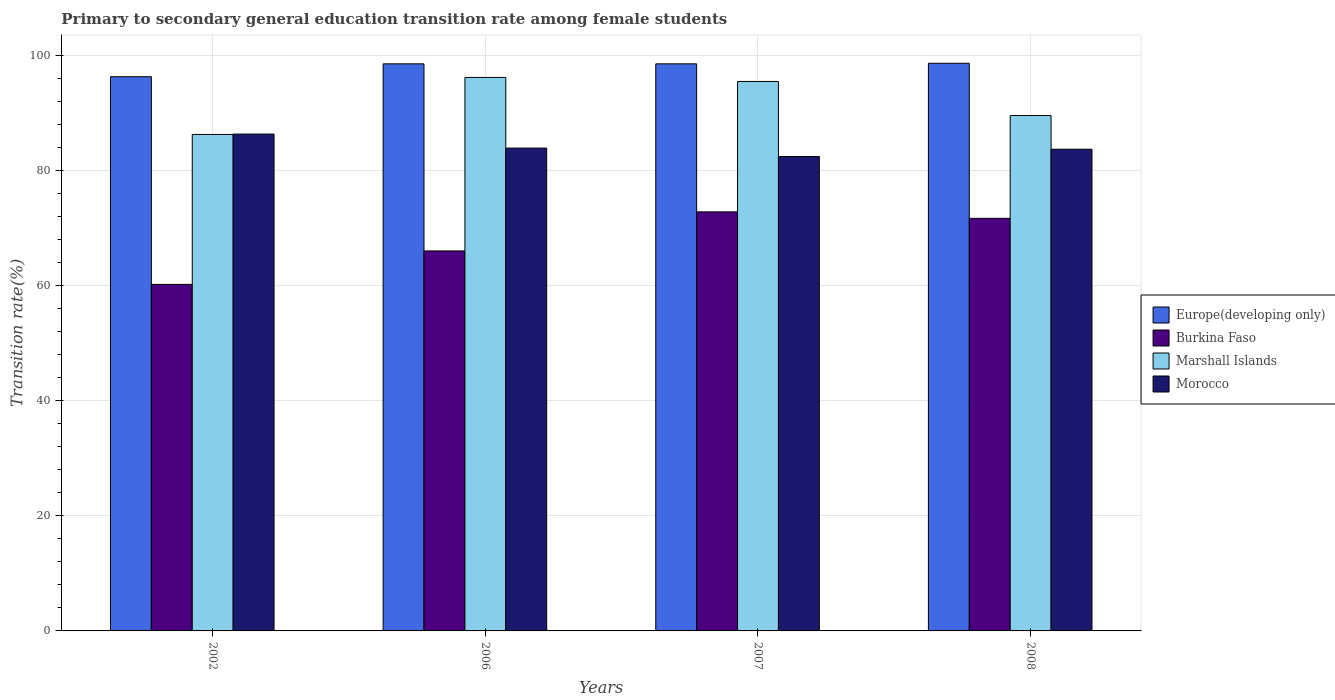How many different coloured bars are there?
Keep it short and to the point. 4. How many groups of bars are there?
Give a very brief answer. 4. How many bars are there on the 2nd tick from the left?
Provide a succinct answer. 4. What is the label of the 4th group of bars from the left?
Your answer should be very brief. 2008. In how many cases, is the number of bars for a given year not equal to the number of legend labels?
Your answer should be very brief. 0. What is the transition rate in Burkina Faso in 2008?
Make the answer very short. 71.7. Across all years, what is the maximum transition rate in Europe(developing only)?
Offer a terse response. 98.65. Across all years, what is the minimum transition rate in Europe(developing only)?
Your answer should be very brief. 96.31. In which year was the transition rate in Europe(developing only) minimum?
Provide a short and direct response. 2002. What is the total transition rate in Burkina Faso in the graph?
Offer a very short reply. 270.77. What is the difference between the transition rate in Morocco in 2006 and that in 2007?
Offer a terse response. 1.47. What is the difference between the transition rate in Marshall Islands in 2008 and the transition rate in Burkina Faso in 2007?
Your answer should be compact. 16.74. What is the average transition rate in Morocco per year?
Your answer should be very brief. 84.1. In the year 2008, what is the difference between the transition rate in Morocco and transition rate in Europe(developing only)?
Your response must be concise. -14.94. In how many years, is the transition rate in Marshall Islands greater than 20 %?
Ensure brevity in your answer.  4. What is the ratio of the transition rate in Burkina Faso in 2006 to that in 2008?
Provide a succinct answer. 0.92. What is the difference between the highest and the second highest transition rate in Europe(developing only)?
Ensure brevity in your answer.  0.1. What is the difference between the highest and the lowest transition rate in Marshall Islands?
Keep it short and to the point. 9.91. In how many years, is the transition rate in Marshall Islands greater than the average transition rate in Marshall Islands taken over all years?
Offer a very short reply. 2. Is it the case that in every year, the sum of the transition rate in Morocco and transition rate in Europe(developing only) is greater than the sum of transition rate in Marshall Islands and transition rate in Burkina Faso?
Offer a very short reply. No. What does the 2nd bar from the left in 2006 represents?
Provide a short and direct response. Burkina Faso. What does the 2nd bar from the right in 2002 represents?
Your answer should be compact. Marshall Islands. Is it the case that in every year, the sum of the transition rate in Morocco and transition rate in Burkina Faso is greater than the transition rate in Europe(developing only)?
Provide a short and direct response. Yes. How many bars are there?
Provide a short and direct response. 16. What is the difference between two consecutive major ticks on the Y-axis?
Your answer should be very brief. 20. Are the values on the major ticks of Y-axis written in scientific E-notation?
Provide a short and direct response. No. Does the graph contain grids?
Provide a short and direct response. Yes. How many legend labels are there?
Keep it short and to the point. 4. How are the legend labels stacked?
Ensure brevity in your answer.  Vertical. What is the title of the graph?
Give a very brief answer. Primary to secondary general education transition rate among female students. What is the label or title of the Y-axis?
Provide a succinct answer. Transition rate(%). What is the Transition rate(%) of Europe(developing only) in 2002?
Provide a short and direct response. 96.31. What is the Transition rate(%) in Burkina Faso in 2002?
Provide a short and direct response. 60.22. What is the Transition rate(%) in Marshall Islands in 2002?
Ensure brevity in your answer.  86.27. What is the Transition rate(%) of Morocco in 2002?
Keep it short and to the point. 86.34. What is the Transition rate(%) in Europe(developing only) in 2006?
Offer a terse response. 98.55. What is the Transition rate(%) of Burkina Faso in 2006?
Offer a very short reply. 66.03. What is the Transition rate(%) of Marshall Islands in 2006?
Give a very brief answer. 96.19. What is the Transition rate(%) of Morocco in 2006?
Provide a succinct answer. 83.91. What is the Transition rate(%) of Europe(developing only) in 2007?
Make the answer very short. 98.55. What is the Transition rate(%) in Burkina Faso in 2007?
Offer a terse response. 72.82. What is the Transition rate(%) in Marshall Islands in 2007?
Keep it short and to the point. 95.48. What is the Transition rate(%) of Morocco in 2007?
Offer a very short reply. 82.44. What is the Transition rate(%) of Europe(developing only) in 2008?
Offer a terse response. 98.65. What is the Transition rate(%) in Burkina Faso in 2008?
Your answer should be compact. 71.7. What is the Transition rate(%) in Marshall Islands in 2008?
Keep it short and to the point. 89.57. What is the Transition rate(%) of Morocco in 2008?
Make the answer very short. 83.71. Across all years, what is the maximum Transition rate(%) of Europe(developing only)?
Ensure brevity in your answer.  98.65. Across all years, what is the maximum Transition rate(%) in Burkina Faso?
Offer a very short reply. 72.82. Across all years, what is the maximum Transition rate(%) in Marshall Islands?
Your answer should be compact. 96.19. Across all years, what is the maximum Transition rate(%) of Morocco?
Ensure brevity in your answer.  86.34. Across all years, what is the minimum Transition rate(%) of Europe(developing only)?
Your answer should be very brief. 96.31. Across all years, what is the minimum Transition rate(%) in Burkina Faso?
Your answer should be very brief. 60.22. Across all years, what is the minimum Transition rate(%) of Marshall Islands?
Keep it short and to the point. 86.27. Across all years, what is the minimum Transition rate(%) of Morocco?
Offer a terse response. 82.44. What is the total Transition rate(%) in Europe(developing only) in the graph?
Your answer should be very brief. 392.06. What is the total Transition rate(%) in Burkina Faso in the graph?
Your response must be concise. 270.77. What is the total Transition rate(%) in Marshall Islands in the graph?
Your answer should be compact. 367.51. What is the total Transition rate(%) in Morocco in the graph?
Provide a short and direct response. 336.4. What is the difference between the Transition rate(%) of Europe(developing only) in 2002 and that in 2006?
Make the answer very short. -2.24. What is the difference between the Transition rate(%) of Burkina Faso in 2002 and that in 2006?
Your answer should be very brief. -5.82. What is the difference between the Transition rate(%) in Marshall Islands in 2002 and that in 2006?
Your response must be concise. -9.91. What is the difference between the Transition rate(%) of Morocco in 2002 and that in 2006?
Your answer should be very brief. 2.44. What is the difference between the Transition rate(%) of Europe(developing only) in 2002 and that in 2007?
Your answer should be very brief. -2.24. What is the difference between the Transition rate(%) in Burkina Faso in 2002 and that in 2007?
Offer a very short reply. -12.6. What is the difference between the Transition rate(%) in Marshall Islands in 2002 and that in 2007?
Make the answer very short. -9.21. What is the difference between the Transition rate(%) in Morocco in 2002 and that in 2007?
Your response must be concise. 3.9. What is the difference between the Transition rate(%) of Europe(developing only) in 2002 and that in 2008?
Make the answer very short. -2.34. What is the difference between the Transition rate(%) in Burkina Faso in 2002 and that in 2008?
Provide a succinct answer. -11.48. What is the difference between the Transition rate(%) in Marshall Islands in 2002 and that in 2008?
Give a very brief answer. -3.29. What is the difference between the Transition rate(%) in Morocco in 2002 and that in 2008?
Offer a terse response. 2.63. What is the difference between the Transition rate(%) in Europe(developing only) in 2006 and that in 2007?
Offer a terse response. -0. What is the difference between the Transition rate(%) in Burkina Faso in 2006 and that in 2007?
Your response must be concise. -6.79. What is the difference between the Transition rate(%) in Marshall Islands in 2006 and that in 2007?
Your answer should be compact. 0.7. What is the difference between the Transition rate(%) of Morocco in 2006 and that in 2007?
Offer a terse response. 1.47. What is the difference between the Transition rate(%) of Europe(developing only) in 2006 and that in 2008?
Provide a succinct answer. -0.1. What is the difference between the Transition rate(%) in Burkina Faso in 2006 and that in 2008?
Your response must be concise. -5.66. What is the difference between the Transition rate(%) in Marshall Islands in 2006 and that in 2008?
Offer a very short reply. 6.62. What is the difference between the Transition rate(%) of Morocco in 2006 and that in 2008?
Keep it short and to the point. 0.2. What is the difference between the Transition rate(%) of Europe(developing only) in 2007 and that in 2008?
Offer a terse response. -0.1. What is the difference between the Transition rate(%) of Burkina Faso in 2007 and that in 2008?
Provide a succinct answer. 1.13. What is the difference between the Transition rate(%) of Marshall Islands in 2007 and that in 2008?
Make the answer very short. 5.92. What is the difference between the Transition rate(%) in Morocco in 2007 and that in 2008?
Your answer should be very brief. -1.27. What is the difference between the Transition rate(%) of Europe(developing only) in 2002 and the Transition rate(%) of Burkina Faso in 2006?
Offer a terse response. 30.28. What is the difference between the Transition rate(%) of Europe(developing only) in 2002 and the Transition rate(%) of Marshall Islands in 2006?
Provide a succinct answer. 0.12. What is the difference between the Transition rate(%) of Europe(developing only) in 2002 and the Transition rate(%) of Morocco in 2006?
Your response must be concise. 12.4. What is the difference between the Transition rate(%) in Burkina Faso in 2002 and the Transition rate(%) in Marshall Islands in 2006?
Make the answer very short. -35.97. What is the difference between the Transition rate(%) of Burkina Faso in 2002 and the Transition rate(%) of Morocco in 2006?
Your answer should be very brief. -23.69. What is the difference between the Transition rate(%) in Marshall Islands in 2002 and the Transition rate(%) in Morocco in 2006?
Your answer should be very brief. 2.37. What is the difference between the Transition rate(%) in Europe(developing only) in 2002 and the Transition rate(%) in Burkina Faso in 2007?
Your answer should be very brief. 23.49. What is the difference between the Transition rate(%) of Europe(developing only) in 2002 and the Transition rate(%) of Marshall Islands in 2007?
Keep it short and to the point. 0.83. What is the difference between the Transition rate(%) in Europe(developing only) in 2002 and the Transition rate(%) in Morocco in 2007?
Ensure brevity in your answer.  13.87. What is the difference between the Transition rate(%) of Burkina Faso in 2002 and the Transition rate(%) of Marshall Islands in 2007?
Ensure brevity in your answer.  -35.27. What is the difference between the Transition rate(%) of Burkina Faso in 2002 and the Transition rate(%) of Morocco in 2007?
Provide a short and direct response. -22.22. What is the difference between the Transition rate(%) of Marshall Islands in 2002 and the Transition rate(%) of Morocco in 2007?
Offer a very short reply. 3.84. What is the difference between the Transition rate(%) of Europe(developing only) in 2002 and the Transition rate(%) of Burkina Faso in 2008?
Give a very brief answer. 24.62. What is the difference between the Transition rate(%) of Europe(developing only) in 2002 and the Transition rate(%) of Marshall Islands in 2008?
Your response must be concise. 6.75. What is the difference between the Transition rate(%) in Europe(developing only) in 2002 and the Transition rate(%) in Morocco in 2008?
Keep it short and to the point. 12.6. What is the difference between the Transition rate(%) of Burkina Faso in 2002 and the Transition rate(%) of Marshall Islands in 2008?
Keep it short and to the point. -29.35. What is the difference between the Transition rate(%) of Burkina Faso in 2002 and the Transition rate(%) of Morocco in 2008?
Ensure brevity in your answer.  -23.49. What is the difference between the Transition rate(%) in Marshall Islands in 2002 and the Transition rate(%) in Morocco in 2008?
Provide a short and direct response. 2.56. What is the difference between the Transition rate(%) in Europe(developing only) in 2006 and the Transition rate(%) in Burkina Faso in 2007?
Your answer should be compact. 25.73. What is the difference between the Transition rate(%) of Europe(developing only) in 2006 and the Transition rate(%) of Marshall Islands in 2007?
Keep it short and to the point. 3.06. What is the difference between the Transition rate(%) in Europe(developing only) in 2006 and the Transition rate(%) in Morocco in 2007?
Offer a terse response. 16.11. What is the difference between the Transition rate(%) in Burkina Faso in 2006 and the Transition rate(%) in Marshall Islands in 2007?
Your answer should be compact. -29.45. What is the difference between the Transition rate(%) of Burkina Faso in 2006 and the Transition rate(%) of Morocco in 2007?
Ensure brevity in your answer.  -16.4. What is the difference between the Transition rate(%) in Marshall Islands in 2006 and the Transition rate(%) in Morocco in 2007?
Your answer should be very brief. 13.75. What is the difference between the Transition rate(%) of Europe(developing only) in 2006 and the Transition rate(%) of Burkina Faso in 2008?
Offer a terse response. 26.85. What is the difference between the Transition rate(%) of Europe(developing only) in 2006 and the Transition rate(%) of Marshall Islands in 2008?
Keep it short and to the point. 8.98. What is the difference between the Transition rate(%) of Europe(developing only) in 2006 and the Transition rate(%) of Morocco in 2008?
Your answer should be compact. 14.84. What is the difference between the Transition rate(%) in Burkina Faso in 2006 and the Transition rate(%) in Marshall Islands in 2008?
Offer a terse response. -23.53. What is the difference between the Transition rate(%) of Burkina Faso in 2006 and the Transition rate(%) of Morocco in 2008?
Give a very brief answer. -17.68. What is the difference between the Transition rate(%) of Marshall Islands in 2006 and the Transition rate(%) of Morocco in 2008?
Provide a succinct answer. 12.48. What is the difference between the Transition rate(%) of Europe(developing only) in 2007 and the Transition rate(%) of Burkina Faso in 2008?
Offer a terse response. 26.85. What is the difference between the Transition rate(%) of Europe(developing only) in 2007 and the Transition rate(%) of Marshall Islands in 2008?
Ensure brevity in your answer.  8.98. What is the difference between the Transition rate(%) in Europe(developing only) in 2007 and the Transition rate(%) in Morocco in 2008?
Offer a terse response. 14.84. What is the difference between the Transition rate(%) of Burkina Faso in 2007 and the Transition rate(%) of Marshall Islands in 2008?
Ensure brevity in your answer.  -16.74. What is the difference between the Transition rate(%) in Burkina Faso in 2007 and the Transition rate(%) in Morocco in 2008?
Ensure brevity in your answer.  -10.89. What is the difference between the Transition rate(%) of Marshall Islands in 2007 and the Transition rate(%) of Morocco in 2008?
Your response must be concise. 11.77. What is the average Transition rate(%) in Europe(developing only) per year?
Keep it short and to the point. 98.01. What is the average Transition rate(%) in Burkina Faso per year?
Make the answer very short. 67.69. What is the average Transition rate(%) in Marshall Islands per year?
Make the answer very short. 91.88. What is the average Transition rate(%) in Morocco per year?
Provide a short and direct response. 84.1. In the year 2002, what is the difference between the Transition rate(%) in Europe(developing only) and Transition rate(%) in Burkina Faso?
Give a very brief answer. 36.09. In the year 2002, what is the difference between the Transition rate(%) in Europe(developing only) and Transition rate(%) in Marshall Islands?
Ensure brevity in your answer.  10.04. In the year 2002, what is the difference between the Transition rate(%) in Europe(developing only) and Transition rate(%) in Morocco?
Provide a short and direct response. 9.97. In the year 2002, what is the difference between the Transition rate(%) of Burkina Faso and Transition rate(%) of Marshall Islands?
Your response must be concise. -26.06. In the year 2002, what is the difference between the Transition rate(%) in Burkina Faso and Transition rate(%) in Morocco?
Provide a short and direct response. -26.12. In the year 2002, what is the difference between the Transition rate(%) of Marshall Islands and Transition rate(%) of Morocco?
Offer a very short reply. -0.07. In the year 2006, what is the difference between the Transition rate(%) in Europe(developing only) and Transition rate(%) in Burkina Faso?
Provide a succinct answer. 32.52. In the year 2006, what is the difference between the Transition rate(%) of Europe(developing only) and Transition rate(%) of Marshall Islands?
Your answer should be compact. 2.36. In the year 2006, what is the difference between the Transition rate(%) in Europe(developing only) and Transition rate(%) in Morocco?
Give a very brief answer. 14.64. In the year 2006, what is the difference between the Transition rate(%) of Burkina Faso and Transition rate(%) of Marshall Islands?
Give a very brief answer. -30.15. In the year 2006, what is the difference between the Transition rate(%) in Burkina Faso and Transition rate(%) in Morocco?
Your answer should be very brief. -17.87. In the year 2006, what is the difference between the Transition rate(%) in Marshall Islands and Transition rate(%) in Morocco?
Make the answer very short. 12.28. In the year 2007, what is the difference between the Transition rate(%) in Europe(developing only) and Transition rate(%) in Burkina Faso?
Your answer should be compact. 25.73. In the year 2007, what is the difference between the Transition rate(%) in Europe(developing only) and Transition rate(%) in Marshall Islands?
Ensure brevity in your answer.  3.06. In the year 2007, what is the difference between the Transition rate(%) in Europe(developing only) and Transition rate(%) in Morocco?
Ensure brevity in your answer.  16.11. In the year 2007, what is the difference between the Transition rate(%) in Burkina Faso and Transition rate(%) in Marshall Islands?
Offer a very short reply. -22.66. In the year 2007, what is the difference between the Transition rate(%) in Burkina Faso and Transition rate(%) in Morocco?
Provide a succinct answer. -9.62. In the year 2007, what is the difference between the Transition rate(%) of Marshall Islands and Transition rate(%) of Morocco?
Provide a short and direct response. 13.05. In the year 2008, what is the difference between the Transition rate(%) of Europe(developing only) and Transition rate(%) of Burkina Faso?
Your answer should be compact. 26.95. In the year 2008, what is the difference between the Transition rate(%) of Europe(developing only) and Transition rate(%) of Marshall Islands?
Offer a very short reply. 9.08. In the year 2008, what is the difference between the Transition rate(%) in Europe(developing only) and Transition rate(%) in Morocco?
Ensure brevity in your answer.  14.94. In the year 2008, what is the difference between the Transition rate(%) of Burkina Faso and Transition rate(%) of Marshall Islands?
Your response must be concise. -17.87. In the year 2008, what is the difference between the Transition rate(%) of Burkina Faso and Transition rate(%) of Morocco?
Your answer should be very brief. -12.01. In the year 2008, what is the difference between the Transition rate(%) of Marshall Islands and Transition rate(%) of Morocco?
Make the answer very short. 5.85. What is the ratio of the Transition rate(%) of Europe(developing only) in 2002 to that in 2006?
Your answer should be very brief. 0.98. What is the ratio of the Transition rate(%) in Burkina Faso in 2002 to that in 2006?
Your response must be concise. 0.91. What is the ratio of the Transition rate(%) of Marshall Islands in 2002 to that in 2006?
Your answer should be compact. 0.9. What is the ratio of the Transition rate(%) in Europe(developing only) in 2002 to that in 2007?
Make the answer very short. 0.98. What is the ratio of the Transition rate(%) in Burkina Faso in 2002 to that in 2007?
Offer a very short reply. 0.83. What is the ratio of the Transition rate(%) of Marshall Islands in 2002 to that in 2007?
Provide a short and direct response. 0.9. What is the ratio of the Transition rate(%) of Morocco in 2002 to that in 2007?
Give a very brief answer. 1.05. What is the ratio of the Transition rate(%) in Europe(developing only) in 2002 to that in 2008?
Ensure brevity in your answer.  0.98. What is the ratio of the Transition rate(%) in Burkina Faso in 2002 to that in 2008?
Provide a succinct answer. 0.84. What is the ratio of the Transition rate(%) in Marshall Islands in 2002 to that in 2008?
Offer a very short reply. 0.96. What is the ratio of the Transition rate(%) in Morocco in 2002 to that in 2008?
Offer a very short reply. 1.03. What is the ratio of the Transition rate(%) of Burkina Faso in 2006 to that in 2007?
Keep it short and to the point. 0.91. What is the ratio of the Transition rate(%) of Marshall Islands in 2006 to that in 2007?
Provide a short and direct response. 1.01. What is the ratio of the Transition rate(%) in Morocco in 2006 to that in 2007?
Provide a short and direct response. 1.02. What is the ratio of the Transition rate(%) in Burkina Faso in 2006 to that in 2008?
Provide a succinct answer. 0.92. What is the ratio of the Transition rate(%) in Marshall Islands in 2006 to that in 2008?
Offer a terse response. 1.07. What is the ratio of the Transition rate(%) of Europe(developing only) in 2007 to that in 2008?
Provide a succinct answer. 1. What is the ratio of the Transition rate(%) in Burkina Faso in 2007 to that in 2008?
Keep it short and to the point. 1.02. What is the ratio of the Transition rate(%) in Marshall Islands in 2007 to that in 2008?
Your answer should be compact. 1.07. What is the ratio of the Transition rate(%) of Morocco in 2007 to that in 2008?
Give a very brief answer. 0.98. What is the difference between the highest and the second highest Transition rate(%) in Europe(developing only)?
Provide a succinct answer. 0.1. What is the difference between the highest and the second highest Transition rate(%) of Burkina Faso?
Make the answer very short. 1.13. What is the difference between the highest and the second highest Transition rate(%) in Marshall Islands?
Ensure brevity in your answer.  0.7. What is the difference between the highest and the second highest Transition rate(%) of Morocco?
Provide a succinct answer. 2.44. What is the difference between the highest and the lowest Transition rate(%) in Europe(developing only)?
Make the answer very short. 2.34. What is the difference between the highest and the lowest Transition rate(%) in Burkina Faso?
Ensure brevity in your answer.  12.6. What is the difference between the highest and the lowest Transition rate(%) in Marshall Islands?
Keep it short and to the point. 9.91. What is the difference between the highest and the lowest Transition rate(%) of Morocco?
Provide a succinct answer. 3.9. 